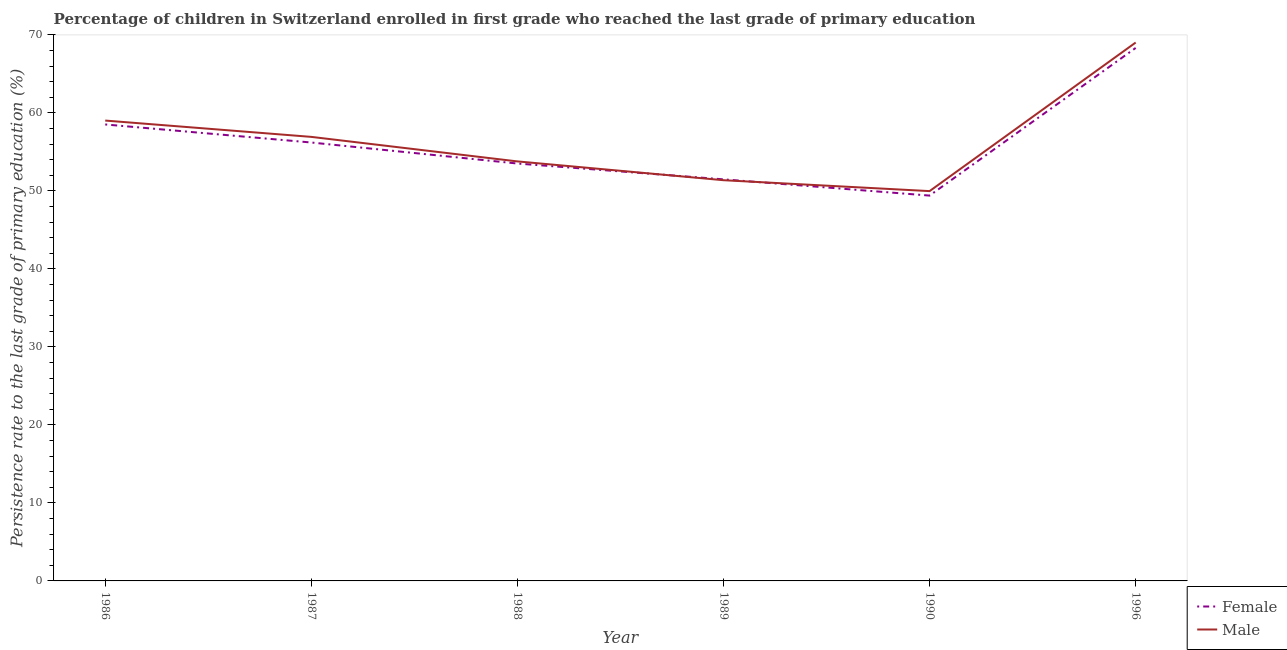Is the number of lines equal to the number of legend labels?
Provide a short and direct response. Yes. What is the persistence rate of female students in 1987?
Provide a short and direct response. 56.2. Across all years, what is the maximum persistence rate of male students?
Ensure brevity in your answer.  69.02. Across all years, what is the minimum persistence rate of male students?
Make the answer very short. 49.97. In which year was the persistence rate of female students minimum?
Provide a succinct answer. 1990. What is the total persistence rate of male students in the graph?
Keep it short and to the point. 340.08. What is the difference between the persistence rate of male students in 1986 and that in 1990?
Provide a succinct answer. 9.04. What is the difference between the persistence rate of male students in 1996 and the persistence rate of female students in 1986?
Your answer should be very brief. 10.5. What is the average persistence rate of male students per year?
Make the answer very short. 56.68. In the year 1996, what is the difference between the persistence rate of female students and persistence rate of male students?
Make the answer very short. -0.69. What is the ratio of the persistence rate of male students in 1988 to that in 1996?
Keep it short and to the point. 0.78. What is the difference between the highest and the second highest persistence rate of male students?
Give a very brief answer. 10. What is the difference between the highest and the lowest persistence rate of female students?
Provide a succinct answer. 18.93. Does the persistence rate of male students monotonically increase over the years?
Provide a short and direct response. No. Is the persistence rate of male students strictly greater than the persistence rate of female students over the years?
Your answer should be very brief. No. Is the persistence rate of male students strictly less than the persistence rate of female students over the years?
Provide a short and direct response. No. What is the difference between two consecutive major ticks on the Y-axis?
Offer a terse response. 10. Does the graph contain any zero values?
Your answer should be very brief. No. Does the graph contain grids?
Keep it short and to the point. No. Where does the legend appear in the graph?
Provide a short and direct response. Bottom right. What is the title of the graph?
Ensure brevity in your answer.  Percentage of children in Switzerland enrolled in first grade who reached the last grade of primary education. Does "% of gross capital formation" appear as one of the legend labels in the graph?
Keep it short and to the point. No. What is the label or title of the Y-axis?
Make the answer very short. Persistence rate to the last grade of primary education (%). What is the Persistence rate to the last grade of primary education (%) in Female in 1986?
Offer a very short reply. 58.52. What is the Persistence rate to the last grade of primary education (%) of Male in 1986?
Give a very brief answer. 59.02. What is the Persistence rate to the last grade of primary education (%) of Female in 1987?
Provide a succinct answer. 56.2. What is the Persistence rate to the last grade of primary education (%) of Male in 1987?
Ensure brevity in your answer.  56.92. What is the Persistence rate to the last grade of primary education (%) in Female in 1988?
Offer a very short reply. 53.51. What is the Persistence rate to the last grade of primary education (%) of Male in 1988?
Keep it short and to the point. 53.78. What is the Persistence rate to the last grade of primary education (%) of Female in 1989?
Your answer should be compact. 51.48. What is the Persistence rate to the last grade of primary education (%) in Male in 1989?
Your response must be concise. 51.37. What is the Persistence rate to the last grade of primary education (%) in Female in 1990?
Offer a very short reply. 49.4. What is the Persistence rate to the last grade of primary education (%) in Male in 1990?
Offer a terse response. 49.97. What is the Persistence rate to the last grade of primary education (%) in Female in 1996?
Provide a short and direct response. 68.33. What is the Persistence rate to the last grade of primary education (%) of Male in 1996?
Ensure brevity in your answer.  69.02. Across all years, what is the maximum Persistence rate to the last grade of primary education (%) of Female?
Your answer should be compact. 68.33. Across all years, what is the maximum Persistence rate to the last grade of primary education (%) of Male?
Keep it short and to the point. 69.02. Across all years, what is the minimum Persistence rate to the last grade of primary education (%) of Female?
Offer a very short reply. 49.4. Across all years, what is the minimum Persistence rate to the last grade of primary education (%) of Male?
Ensure brevity in your answer.  49.97. What is the total Persistence rate to the last grade of primary education (%) in Female in the graph?
Your response must be concise. 337.43. What is the total Persistence rate to the last grade of primary education (%) in Male in the graph?
Your answer should be compact. 340.08. What is the difference between the Persistence rate to the last grade of primary education (%) in Female in 1986 and that in 1987?
Your answer should be compact. 2.32. What is the difference between the Persistence rate to the last grade of primary education (%) of Male in 1986 and that in 1987?
Your answer should be very brief. 2.09. What is the difference between the Persistence rate to the last grade of primary education (%) in Female in 1986 and that in 1988?
Your answer should be very brief. 5.01. What is the difference between the Persistence rate to the last grade of primary education (%) in Male in 1986 and that in 1988?
Make the answer very short. 5.24. What is the difference between the Persistence rate to the last grade of primary education (%) of Female in 1986 and that in 1989?
Your answer should be compact. 7.04. What is the difference between the Persistence rate to the last grade of primary education (%) of Male in 1986 and that in 1989?
Make the answer very short. 7.64. What is the difference between the Persistence rate to the last grade of primary education (%) of Female in 1986 and that in 1990?
Ensure brevity in your answer.  9.12. What is the difference between the Persistence rate to the last grade of primary education (%) of Male in 1986 and that in 1990?
Offer a very short reply. 9.04. What is the difference between the Persistence rate to the last grade of primary education (%) of Female in 1986 and that in 1996?
Ensure brevity in your answer.  -9.81. What is the difference between the Persistence rate to the last grade of primary education (%) in Male in 1986 and that in 1996?
Your response must be concise. -10. What is the difference between the Persistence rate to the last grade of primary education (%) of Female in 1987 and that in 1988?
Your answer should be compact. 2.69. What is the difference between the Persistence rate to the last grade of primary education (%) of Male in 1987 and that in 1988?
Offer a very short reply. 3.14. What is the difference between the Persistence rate to the last grade of primary education (%) in Female in 1987 and that in 1989?
Offer a terse response. 4.72. What is the difference between the Persistence rate to the last grade of primary education (%) in Male in 1987 and that in 1989?
Offer a very short reply. 5.55. What is the difference between the Persistence rate to the last grade of primary education (%) in Female in 1987 and that in 1990?
Give a very brief answer. 6.8. What is the difference between the Persistence rate to the last grade of primary education (%) of Male in 1987 and that in 1990?
Offer a very short reply. 6.95. What is the difference between the Persistence rate to the last grade of primary education (%) of Female in 1987 and that in 1996?
Provide a succinct answer. -12.12. What is the difference between the Persistence rate to the last grade of primary education (%) of Male in 1987 and that in 1996?
Provide a short and direct response. -12.1. What is the difference between the Persistence rate to the last grade of primary education (%) in Female in 1988 and that in 1989?
Ensure brevity in your answer.  2.03. What is the difference between the Persistence rate to the last grade of primary education (%) in Male in 1988 and that in 1989?
Offer a terse response. 2.41. What is the difference between the Persistence rate to the last grade of primary education (%) of Female in 1988 and that in 1990?
Your answer should be very brief. 4.11. What is the difference between the Persistence rate to the last grade of primary education (%) of Male in 1988 and that in 1990?
Ensure brevity in your answer.  3.81. What is the difference between the Persistence rate to the last grade of primary education (%) of Female in 1988 and that in 1996?
Ensure brevity in your answer.  -14.82. What is the difference between the Persistence rate to the last grade of primary education (%) in Male in 1988 and that in 1996?
Offer a terse response. -15.24. What is the difference between the Persistence rate to the last grade of primary education (%) in Female in 1989 and that in 1990?
Provide a succinct answer. 2.08. What is the difference between the Persistence rate to the last grade of primary education (%) of Male in 1989 and that in 1990?
Your response must be concise. 1.4. What is the difference between the Persistence rate to the last grade of primary education (%) of Female in 1989 and that in 1996?
Give a very brief answer. -16.85. What is the difference between the Persistence rate to the last grade of primary education (%) of Male in 1989 and that in 1996?
Your answer should be very brief. -17.65. What is the difference between the Persistence rate to the last grade of primary education (%) of Female in 1990 and that in 1996?
Make the answer very short. -18.93. What is the difference between the Persistence rate to the last grade of primary education (%) in Male in 1990 and that in 1996?
Offer a very short reply. -19.05. What is the difference between the Persistence rate to the last grade of primary education (%) in Female in 1986 and the Persistence rate to the last grade of primary education (%) in Male in 1987?
Give a very brief answer. 1.59. What is the difference between the Persistence rate to the last grade of primary education (%) of Female in 1986 and the Persistence rate to the last grade of primary education (%) of Male in 1988?
Make the answer very short. 4.74. What is the difference between the Persistence rate to the last grade of primary education (%) of Female in 1986 and the Persistence rate to the last grade of primary education (%) of Male in 1989?
Offer a very short reply. 7.15. What is the difference between the Persistence rate to the last grade of primary education (%) in Female in 1986 and the Persistence rate to the last grade of primary education (%) in Male in 1990?
Your answer should be compact. 8.55. What is the difference between the Persistence rate to the last grade of primary education (%) of Female in 1986 and the Persistence rate to the last grade of primary education (%) of Male in 1996?
Offer a very short reply. -10.5. What is the difference between the Persistence rate to the last grade of primary education (%) of Female in 1987 and the Persistence rate to the last grade of primary education (%) of Male in 1988?
Ensure brevity in your answer.  2.42. What is the difference between the Persistence rate to the last grade of primary education (%) of Female in 1987 and the Persistence rate to the last grade of primary education (%) of Male in 1989?
Provide a succinct answer. 4.83. What is the difference between the Persistence rate to the last grade of primary education (%) of Female in 1987 and the Persistence rate to the last grade of primary education (%) of Male in 1990?
Provide a succinct answer. 6.23. What is the difference between the Persistence rate to the last grade of primary education (%) in Female in 1987 and the Persistence rate to the last grade of primary education (%) in Male in 1996?
Ensure brevity in your answer.  -12.82. What is the difference between the Persistence rate to the last grade of primary education (%) of Female in 1988 and the Persistence rate to the last grade of primary education (%) of Male in 1989?
Provide a short and direct response. 2.14. What is the difference between the Persistence rate to the last grade of primary education (%) in Female in 1988 and the Persistence rate to the last grade of primary education (%) in Male in 1990?
Provide a succinct answer. 3.54. What is the difference between the Persistence rate to the last grade of primary education (%) of Female in 1988 and the Persistence rate to the last grade of primary education (%) of Male in 1996?
Give a very brief answer. -15.51. What is the difference between the Persistence rate to the last grade of primary education (%) of Female in 1989 and the Persistence rate to the last grade of primary education (%) of Male in 1990?
Your answer should be compact. 1.51. What is the difference between the Persistence rate to the last grade of primary education (%) of Female in 1989 and the Persistence rate to the last grade of primary education (%) of Male in 1996?
Make the answer very short. -17.54. What is the difference between the Persistence rate to the last grade of primary education (%) of Female in 1990 and the Persistence rate to the last grade of primary education (%) of Male in 1996?
Offer a very short reply. -19.62. What is the average Persistence rate to the last grade of primary education (%) of Female per year?
Offer a very short reply. 56.24. What is the average Persistence rate to the last grade of primary education (%) in Male per year?
Your response must be concise. 56.68. In the year 1986, what is the difference between the Persistence rate to the last grade of primary education (%) in Female and Persistence rate to the last grade of primary education (%) in Male?
Your answer should be compact. -0.5. In the year 1987, what is the difference between the Persistence rate to the last grade of primary education (%) of Female and Persistence rate to the last grade of primary education (%) of Male?
Ensure brevity in your answer.  -0.72. In the year 1988, what is the difference between the Persistence rate to the last grade of primary education (%) in Female and Persistence rate to the last grade of primary education (%) in Male?
Provide a succinct answer. -0.27. In the year 1989, what is the difference between the Persistence rate to the last grade of primary education (%) in Female and Persistence rate to the last grade of primary education (%) in Male?
Provide a short and direct response. 0.11. In the year 1990, what is the difference between the Persistence rate to the last grade of primary education (%) of Female and Persistence rate to the last grade of primary education (%) of Male?
Offer a terse response. -0.57. In the year 1996, what is the difference between the Persistence rate to the last grade of primary education (%) of Female and Persistence rate to the last grade of primary education (%) of Male?
Keep it short and to the point. -0.69. What is the ratio of the Persistence rate to the last grade of primary education (%) of Female in 1986 to that in 1987?
Keep it short and to the point. 1.04. What is the ratio of the Persistence rate to the last grade of primary education (%) of Male in 1986 to that in 1987?
Offer a very short reply. 1.04. What is the ratio of the Persistence rate to the last grade of primary education (%) in Female in 1986 to that in 1988?
Offer a terse response. 1.09. What is the ratio of the Persistence rate to the last grade of primary education (%) of Male in 1986 to that in 1988?
Provide a short and direct response. 1.1. What is the ratio of the Persistence rate to the last grade of primary education (%) in Female in 1986 to that in 1989?
Provide a succinct answer. 1.14. What is the ratio of the Persistence rate to the last grade of primary education (%) in Male in 1986 to that in 1989?
Make the answer very short. 1.15. What is the ratio of the Persistence rate to the last grade of primary education (%) in Female in 1986 to that in 1990?
Offer a very short reply. 1.18. What is the ratio of the Persistence rate to the last grade of primary education (%) of Male in 1986 to that in 1990?
Ensure brevity in your answer.  1.18. What is the ratio of the Persistence rate to the last grade of primary education (%) of Female in 1986 to that in 1996?
Ensure brevity in your answer.  0.86. What is the ratio of the Persistence rate to the last grade of primary education (%) in Male in 1986 to that in 1996?
Give a very brief answer. 0.86. What is the ratio of the Persistence rate to the last grade of primary education (%) in Female in 1987 to that in 1988?
Offer a very short reply. 1.05. What is the ratio of the Persistence rate to the last grade of primary education (%) in Male in 1987 to that in 1988?
Your answer should be compact. 1.06. What is the ratio of the Persistence rate to the last grade of primary education (%) in Female in 1987 to that in 1989?
Your response must be concise. 1.09. What is the ratio of the Persistence rate to the last grade of primary education (%) in Male in 1987 to that in 1989?
Ensure brevity in your answer.  1.11. What is the ratio of the Persistence rate to the last grade of primary education (%) of Female in 1987 to that in 1990?
Make the answer very short. 1.14. What is the ratio of the Persistence rate to the last grade of primary education (%) in Male in 1987 to that in 1990?
Your answer should be very brief. 1.14. What is the ratio of the Persistence rate to the last grade of primary education (%) of Female in 1987 to that in 1996?
Offer a terse response. 0.82. What is the ratio of the Persistence rate to the last grade of primary education (%) of Male in 1987 to that in 1996?
Offer a terse response. 0.82. What is the ratio of the Persistence rate to the last grade of primary education (%) in Female in 1988 to that in 1989?
Provide a succinct answer. 1.04. What is the ratio of the Persistence rate to the last grade of primary education (%) of Male in 1988 to that in 1989?
Your answer should be very brief. 1.05. What is the ratio of the Persistence rate to the last grade of primary education (%) in Female in 1988 to that in 1990?
Offer a terse response. 1.08. What is the ratio of the Persistence rate to the last grade of primary education (%) of Male in 1988 to that in 1990?
Your answer should be compact. 1.08. What is the ratio of the Persistence rate to the last grade of primary education (%) of Female in 1988 to that in 1996?
Your answer should be compact. 0.78. What is the ratio of the Persistence rate to the last grade of primary education (%) in Male in 1988 to that in 1996?
Ensure brevity in your answer.  0.78. What is the ratio of the Persistence rate to the last grade of primary education (%) in Female in 1989 to that in 1990?
Offer a very short reply. 1.04. What is the ratio of the Persistence rate to the last grade of primary education (%) of Male in 1989 to that in 1990?
Provide a short and direct response. 1.03. What is the ratio of the Persistence rate to the last grade of primary education (%) of Female in 1989 to that in 1996?
Offer a terse response. 0.75. What is the ratio of the Persistence rate to the last grade of primary education (%) of Male in 1989 to that in 1996?
Your answer should be compact. 0.74. What is the ratio of the Persistence rate to the last grade of primary education (%) in Female in 1990 to that in 1996?
Your answer should be very brief. 0.72. What is the ratio of the Persistence rate to the last grade of primary education (%) in Male in 1990 to that in 1996?
Give a very brief answer. 0.72. What is the difference between the highest and the second highest Persistence rate to the last grade of primary education (%) in Female?
Keep it short and to the point. 9.81. What is the difference between the highest and the second highest Persistence rate to the last grade of primary education (%) of Male?
Make the answer very short. 10. What is the difference between the highest and the lowest Persistence rate to the last grade of primary education (%) of Female?
Keep it short and to the point. 18.93. What is the difference between the highest and the lowest Persistence rate to the last grade of primary education (%) of Male?
Offer a terse response. 19.05. 